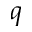Convert formula to latex. <formula><loc_0><loc_0><loc_500><loc_500>q</formula> 